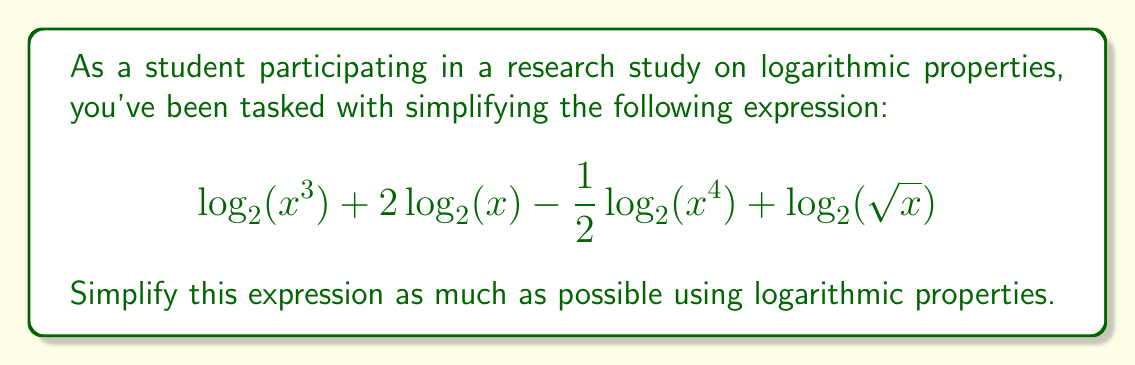Show me your answer to this math problem. Let's simplify this expression step-by-step using logarithmic properties:

1) First, let's apply the power property of logarithms to $\log_2(x^3)$ and $\log_2(x^4)$:
   $$3\log_2(x) + 2\log_2(x) - \frac{1}{2}(4\log_2(x)) + \log_2(\sqrt{x})$$

2) Now, let's simplify $\log_2(\sqrt{x})$:
   $\log_2(\sqrt{x}) = \log_2(x^{\frac{1}{2}}) = \frac{1}{2}\log_2(x)$

3) Our expression now looks like:
   $$3\log_2(x) + 2\log_2(x) - 2\log_2(x) + \frac{1}{2}\log_2(x)$$

4) Let's combine like terms:
   $$3\log_2(x) + 2\log_2(x) - 2\log_2(x) + \frac{1}{2}\log_2(x) = (3 + 2 - 2 + \frac{1}{2})\log_2(x)$$

5) Simplify the coefficient:
   $$(3 + 2 - 2 + \frac{1}{2})\log_2(x) = \frac{7}{2}\log_2(x)$$

Therefore, the simplified expression is $\frac{7}{2}\log_2(x)$.
Answer: $$\frac{7}{2}\log_2(x)$$ 